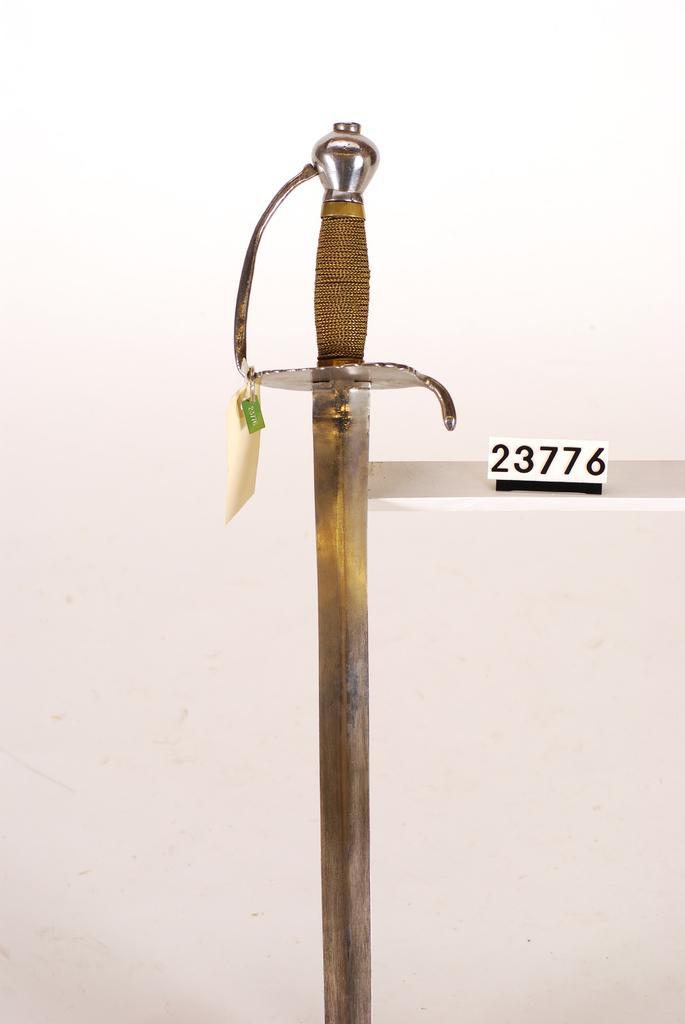Please provide a concise description of this image. In this picture I can see a sword in front and right to the sword I see a white color paper on which there are numbers written and it is white color in the background. 